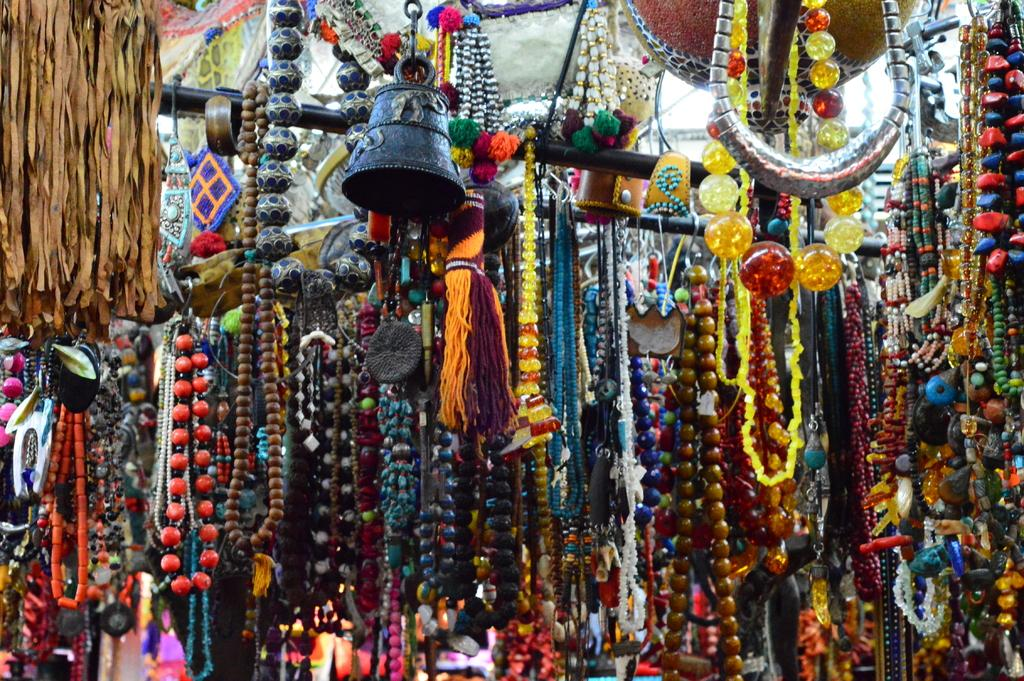What type of establishment is depicted in the image? The image shows the inside view of a shop. What kind of items can be found in the shop? There are many necklaces in the shop. Are there any other decorative elements visible in the image? Yes, there are stone beads hanging in the front of the shop. Can you describe the bell located in the shop? There is a black color bell on the top of the shop. How many cars are parked in front of the shop in the image? There are no cars visible in the image; it shows the inside view of the shop. What type of harmony is being played in the shop? There is no mention of music or harmony in the image; it only shows the interior of the shop with necklaces, stone beads, and a bell. 